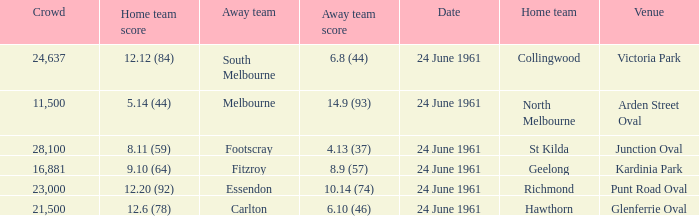Who was the home team that scored 12.6 (78)? Hawthorn. 